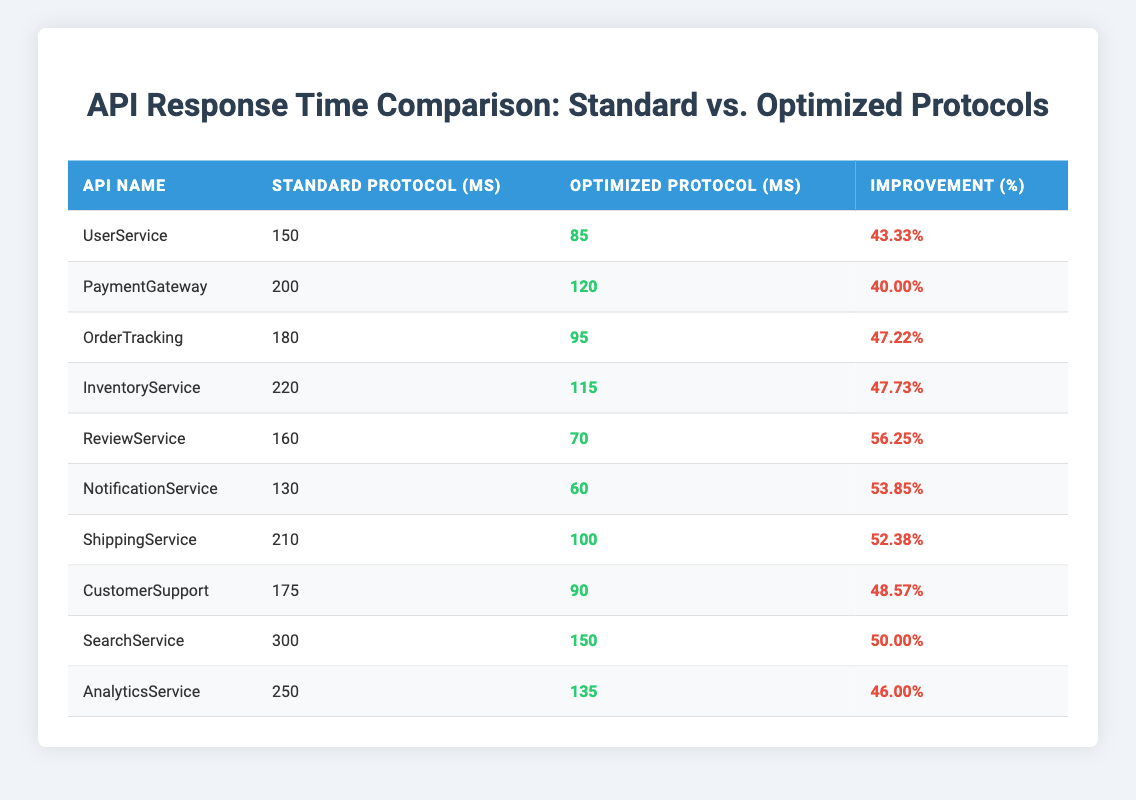What is the fastest response time using an optimized protocol? By scanning the table for the lowest value in the "Optimized Protocol (ms)" column, we find that the minimum is 60 ms for the NotificationService.
Answer: 60 ms Which API has the highest improvement percentage? Looking through the "Improvement (%)" column, the highest percentage is 56.25%, which corresponds to the ReviewService.
Answer: ReviewService What is the difference in response time between the standard and optimized protocols for the ShippingService? The standard protocol time for the ShippingService is 210 ms and the optimized protocol time is 100 ms. The difference is calculated as 210 - 100 = 110 ms.
Answer: 110 ms How many services have an improvement percentage greater than 50%? Counting the respective improvement percentages above 50%, we find 5 services: ReviewService, NotificationService, ShippingService, SearchService, and UserService.
Answer: 5 What is the average response time for the standard protocol across all services? Summing the standard protocol times: 150 + 200 + 180 + 220 + 160 + 130 + 210 + 175 + 300 + 250 = 1,775 ms. There are 10 services, so the average is 1,775 / 10 = 177.5 ms.
Answer: 177.5 ms Is the CustomerSupport API response time improved by more than 40%? The improvement percentage for CustomerSupport is 48.57%, which is greater than 40%. Therefore, the answer is yes.
Answer: Yes What is the total improvement percentage for OrderTracking and InventoryService combined? The individual improvement percentages are 47.22% for OrderTracking and 47.73% for InventoryService. Adding these together gives 47.22 + 47.73 = 94.95%.
Answer: 94.95% Which API has the highest response time using the standard protocol? The highest response time in the "Standard Protocol (ms)" column is 300 ms for the SearchService.
Answer: SearchService What is the median of the optimized protocol response times? The optimized protocol response times are: 85, 120, 95, 115, 70, 60, 100, 90, 150, 135. Sorting these gives: 60, 70, 85, 90, 95, 100, 115, 120, 135, 150. With 10 values, the median is the average of the 5th and 6th values: (95 + 100) / 2 = 97.5 ms.
Answer: 97.5 ms Is the response time for the PaymentGateway using an optimized protocol faster than 100 ms? The optimized protocol time for PaymentGateway is 120 ms, which is not faster than 100 ms.
Answer: No 